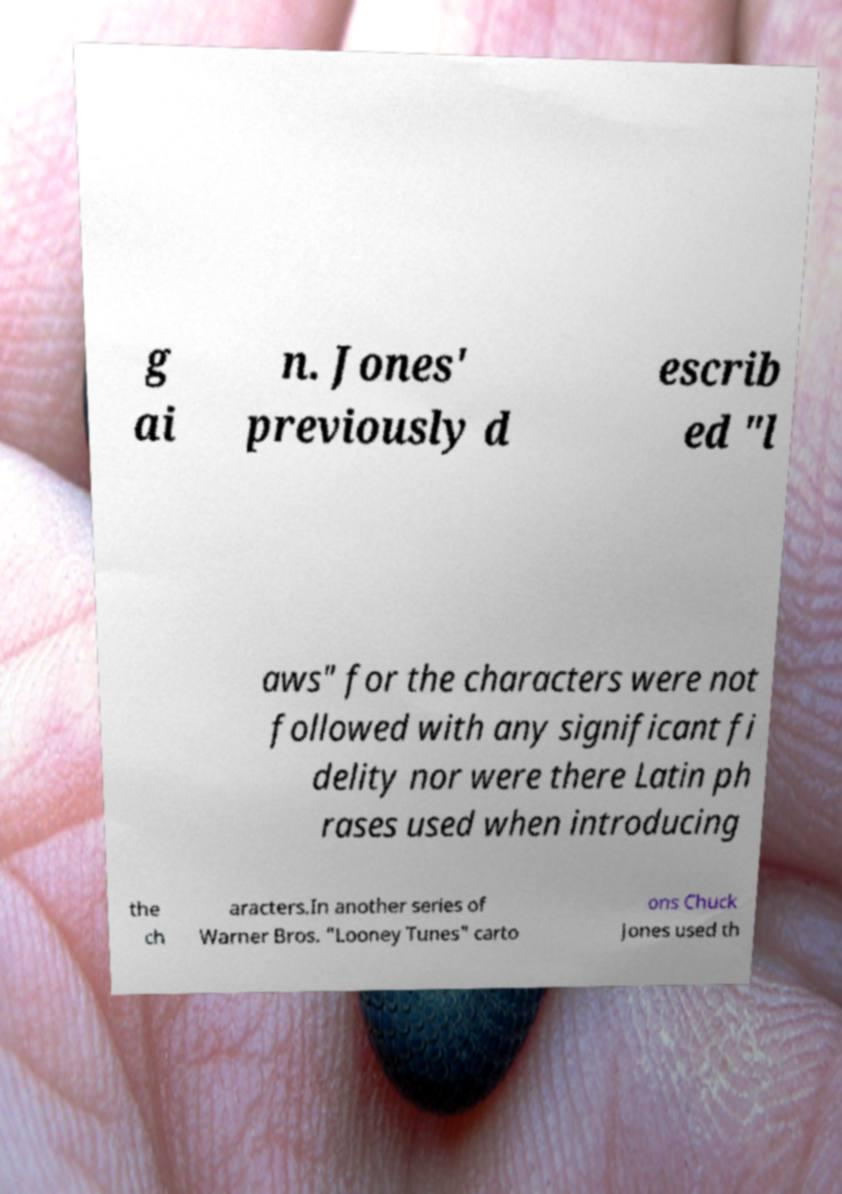Can you read and provide the text displayed in the image?This photo seems to have some interesting text. Can you extract and type it out for me? g ai n. Jones' previously d escrib ed "l aws" for the characters were not followed with any significant fi delity nor were there Latin ph rases used when introducing the ch aracters.In another series of Warner Bros. "Looney Tunes" carto ons Chuck Jones used th 